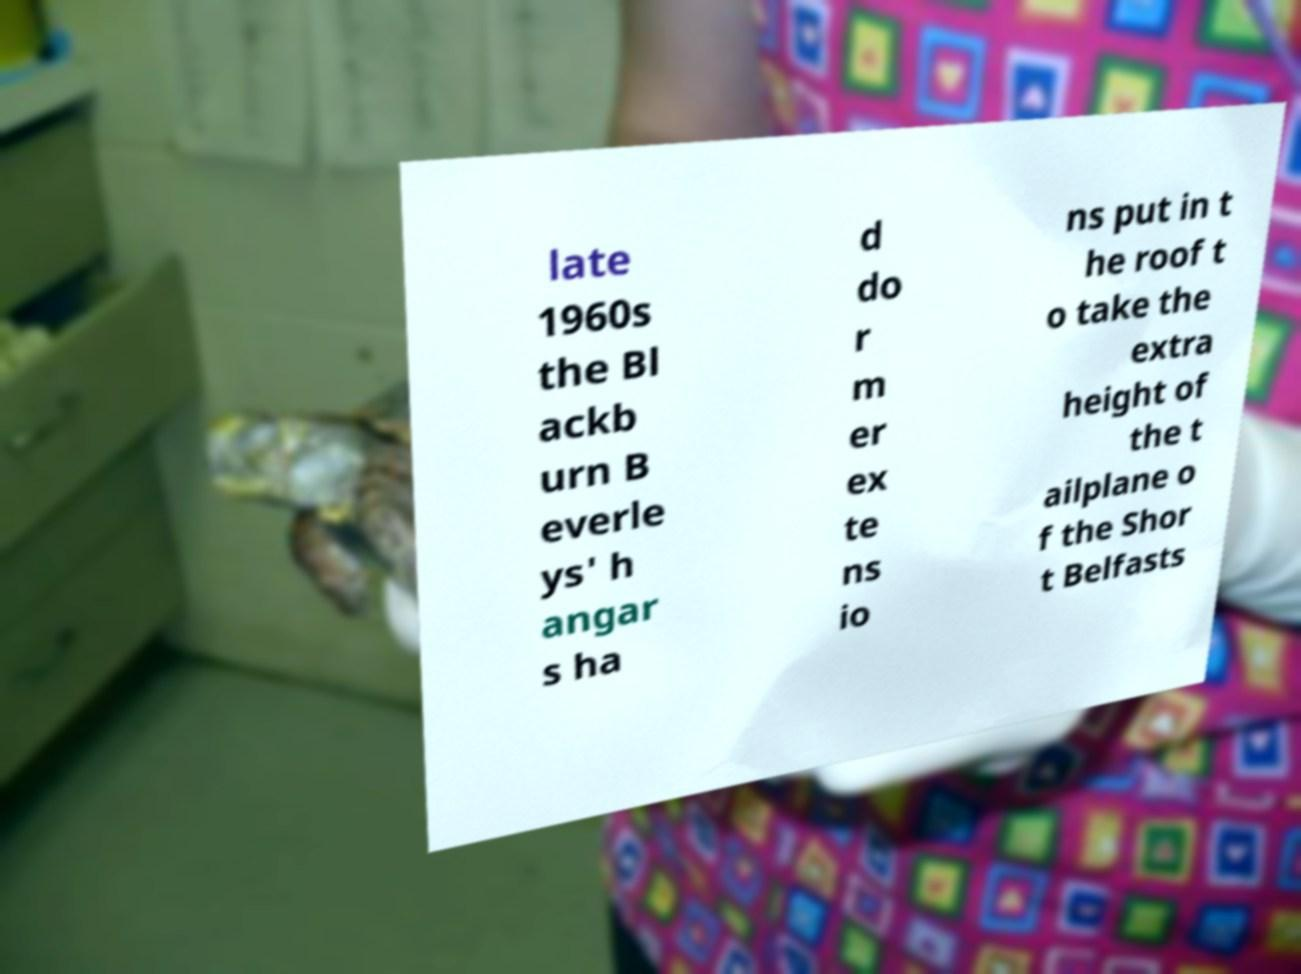For documentation purposes, I need the text within this image transcribed. Could you provide that? late 1960s the Bl ackb urn B everle ys' h angar s ha d do r m er ex te ns io ns put in t he roof t o take the extra height of the t ailplane o f the Shor t Belfasts 